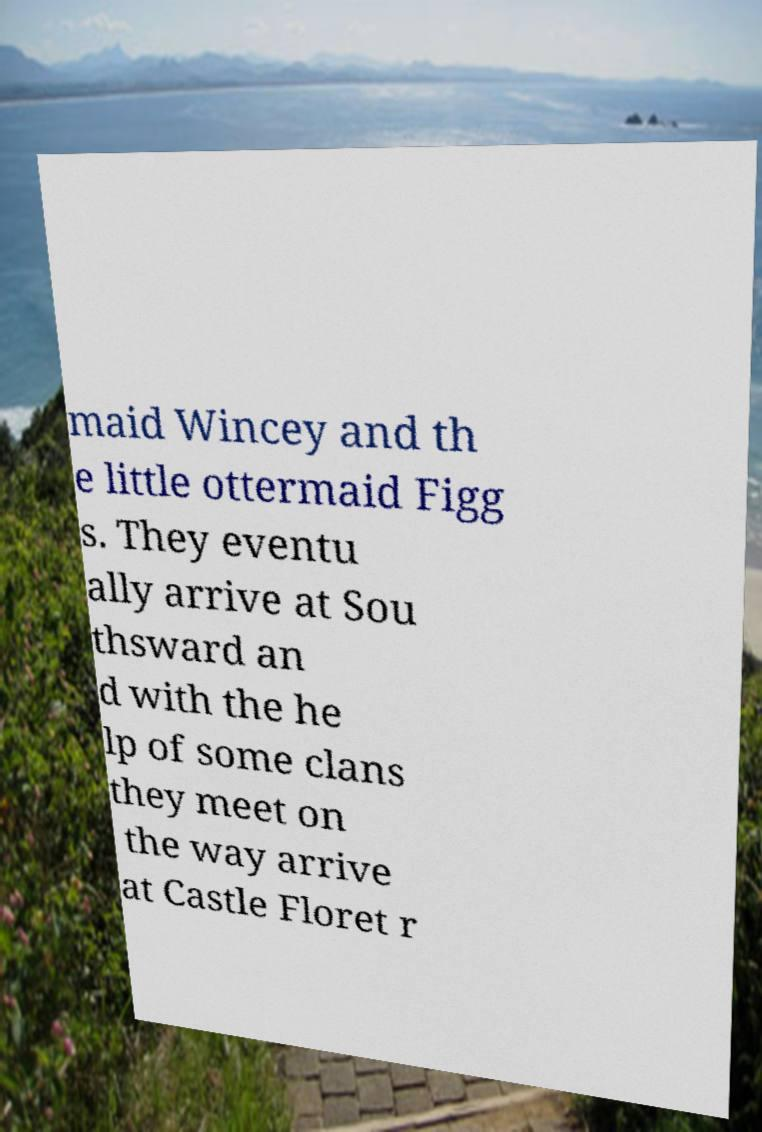Could you assist in decoding the text presented in this image and type it out clearly? maid Wincey and th e little ottermaid Figg s. They eventu ally arrive at Sou thsward an d with the he lp of some clans they meet on the way arrive at Castle Floret r 